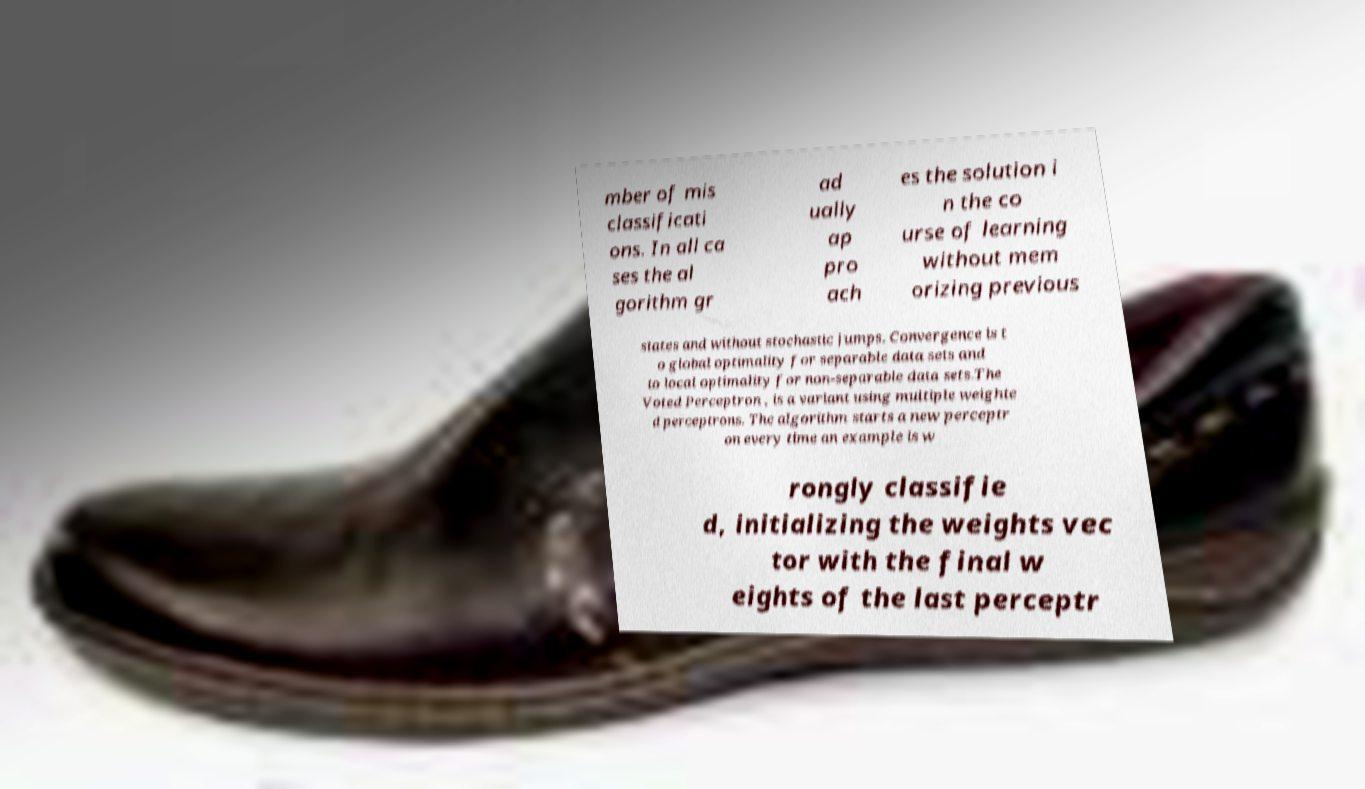Can you read and provide the text displayed in the image?This photo seems to have some interesting text. Can you extract and type it out for me? mber of mis classificati ons. In all ca ses the al gorithm gr ad ually ap pro ach es the solution i n the co urse of learning without mem orizing previous states and without stochastic jumps. Convergence is t o global optimality for separable data sets and to local optimality for non-separable data sets.The Voted Perceptron , is a variant using multiple weighte d perceptrons. The algorithm starts a new perceptr on every time an example is w rongly classifie d, initializing the weights vec tor with the final w eights of the last perceptr 